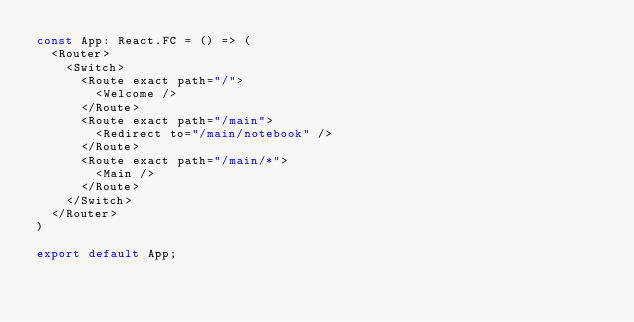<code> <loc_0><loc_0><loc_500><loc_500><_TypeScript_>const App: React.FC = () => (
  <Router>
    <Switch>
      <Route exact path="/">
        <Welcome />
      </Route>
      <Route exact path="/main">
        <Redirect to="/main/notebook" />
      </Route>
      <Route exact path="/main/*">
        <Main />
      </Route>
    </Switch>
  </Router>
)

export default App;
</code> 